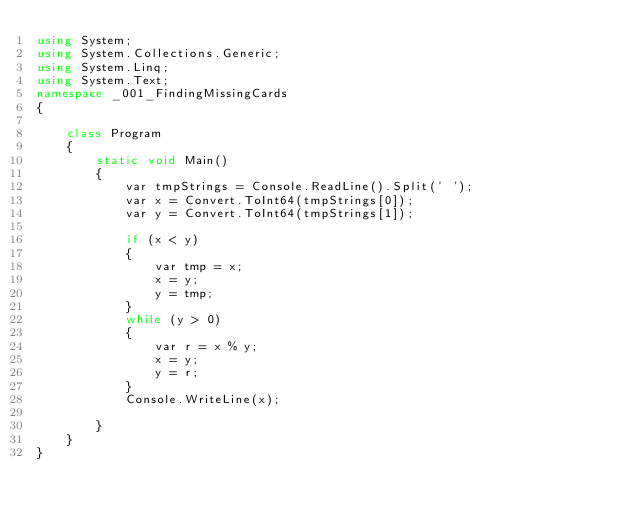<code> <loc_0><loc_0><loc_500><loc_500><_C#_>using System;
using System.Collections.Generic;
using System.Linq;
using System.Text;
namespace _001_FindingMissingCards
{

    class Program
    {
        static void Main()
        {
            var tmpStrings = Console.ReadLine().Split(' ');
            var x = Convert.ToInt64(tmpStrings[0]);
            var y = Convert.ToInt64(tmpStrings[1]);

            if (x < y)
            {
                var tmp = x;
                x = y;
                y = tmp;
            }
            while (y > 0)
            {
                var r = x % y;
                x = y;
                y = r;
            }
            Console.WriteLine(x);

        }
    }
}</code> 